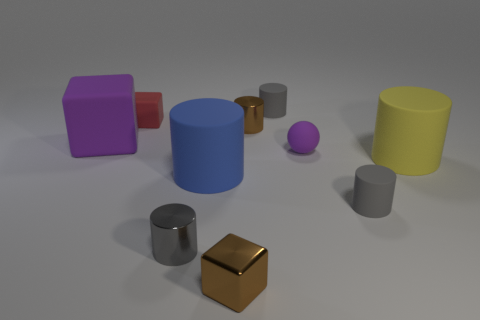There is a big purple object that is made of the same material as the tiny red object; what shape is it?
Ensure brevity in your answer.  Cube. There is a brown thing that is in front of the large blue rubber object; how big is it?
Your answer should be very brief. Small. Are there the same number of small gray metallic things in front of the purple ball and purple rubber cubes in front of the metallic block?
Offer a very short reply. No. The big matte cylinder that is to the right of the block to the right of the metal cylinder to the left of the big blue matte thing is what color?
Make the answer very short. Yellow. What number of rubber things are behind the blue matte cylinder and right of the tiny brown cube?
Your answer should be very brief. 3. There is a small cube behind the large block; does it have the same color as the matte cylinder behind the big purple rubber thing?
Your answer should be very brief. No. Is there any other thing that is made of the same material as the yellow cylinder?
Provide a short and direct response. Yes. There is a brown shiny thing that is the same shape as the tiny gray metallic object; what is its size?
Offer a very short reply. Small. Are there any tiny metal things behind the big matte block?
Offer a very short reply. Yes. Is the number of gray matte cylinders to the left of the purple matte cube the same as the number of yellow matte cylinders?
Your answer should be compact. No. 